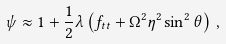<formula> <loc_0><loc_0><loc_500><loc_500>\psi \approx 1 + \frac { 1 } { 2 } \lambda \left ( f _ { t t } + \Omega ^ { 2 } \eta ^ { 2 } \sin ^ { 2 } \theta \right ) \, ,</formula> 